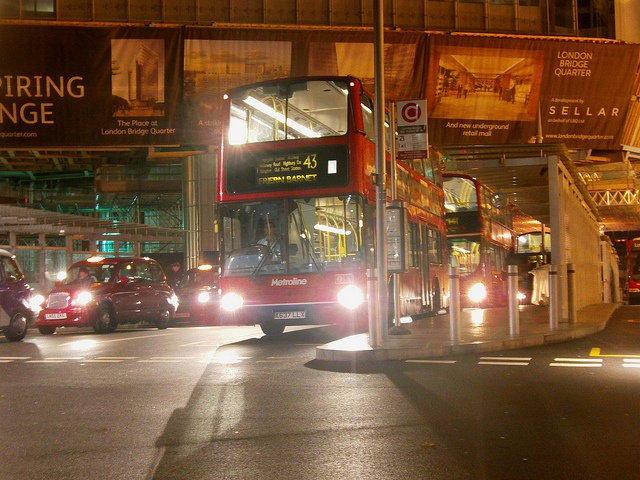Describe the objects in this image and their specific colors. I can see bus in maroon, gray, and tan tones, bus in maroon and brown tones, car in maroon and brown tones, car in maroon, brown, and white tones, and car in maroon, gray, lightpink, and white tones in this image. 